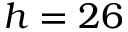Convert formula to latex. <formula><loc_0><loc_0><loc_500><loc_500>h = 2 6</formula> 